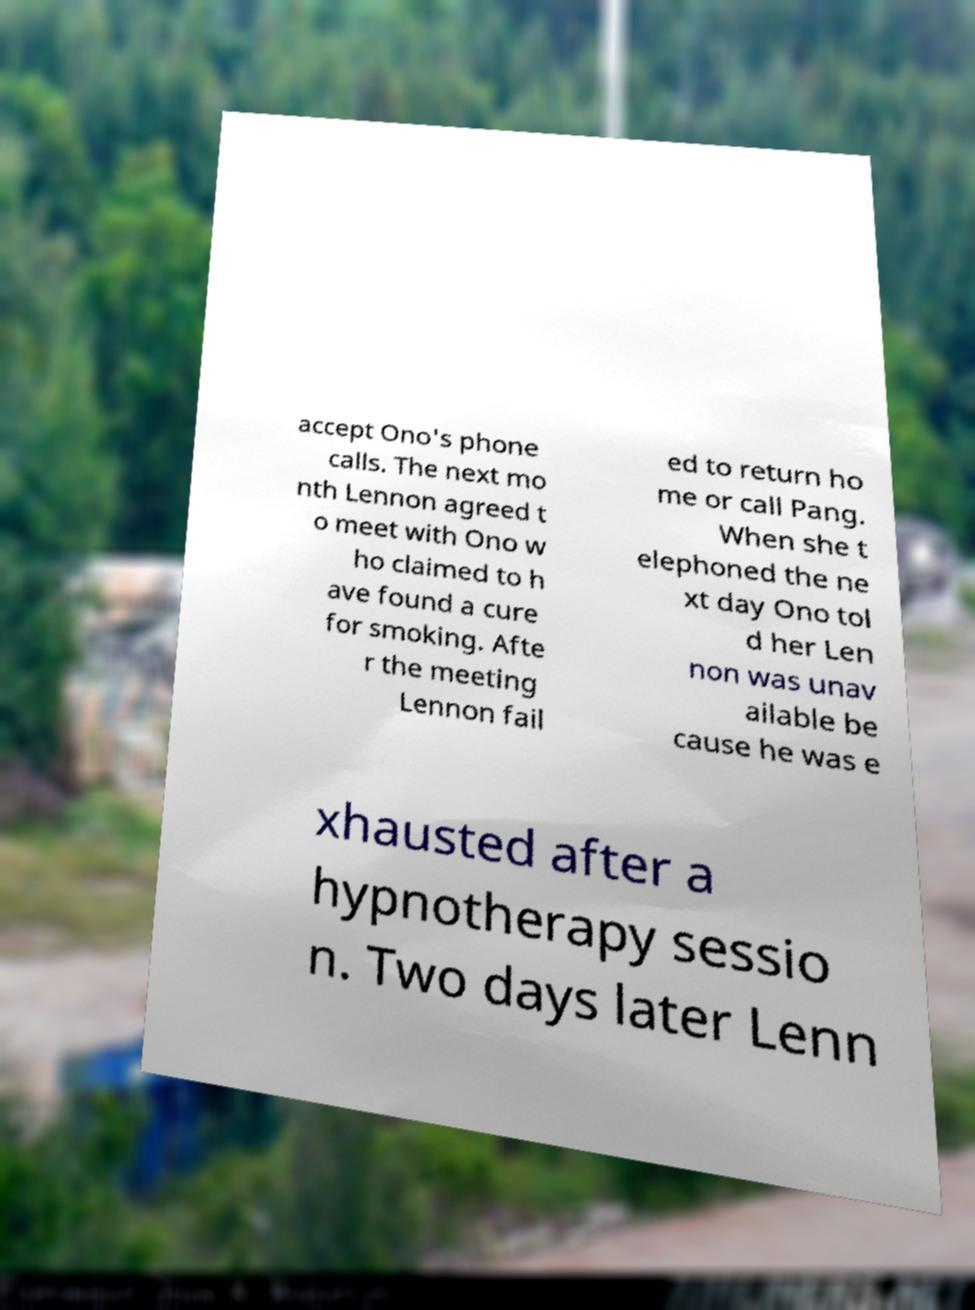I need the written content from this picture converted into text. Can you do that? accept Ono's phone calls. The next mo nth Lennon agreed t o meet with Ono w ho claimed to h ave found a cure for smoking. Afte r the meeting Lennon fail ed to return ho me or call Pang. When she t elephoned the ne xt day Ono tol d her Len non was unav ailable be cause he was e xhausted after a hypnotherapy sessio n. Two days later Lenn 